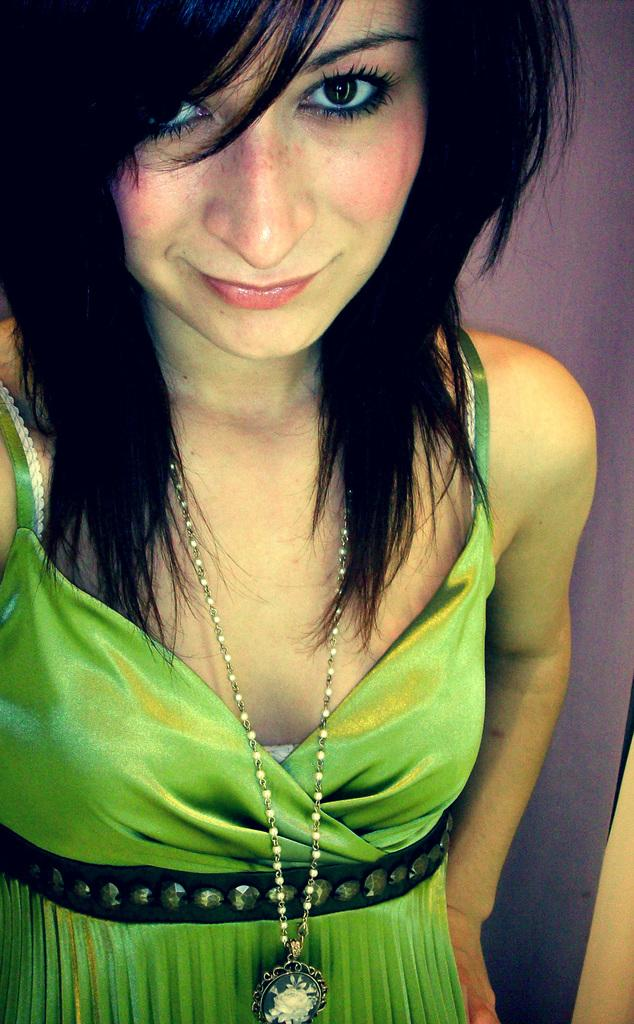Who is the main subject in the image? There is a woman in the image. What is the woman doing in the image? The woman is standing in the image. What is the woman's facial expression in the image? The woman is smiling in the image. What accessory is the woman wearing in the image? The woman is wearing a necklace in the image. What color is the dress the woman is wearing in the image? The woman is wearing a green color dress in the image. What letters can be seen on the insect in the image? There is no insect present in the image, and therefore no letters can be seen on it. 